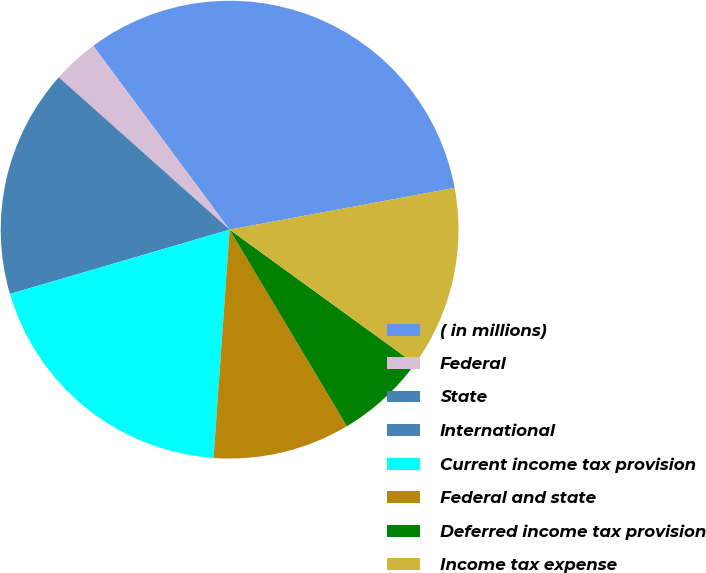Convert chart. <chart><loc_0><loc_0><loc_500><loc_500><pie_chart><fcel>( in millions)<fcel>Federal<fcel>State<fcel>International<fcel>Current income tax provision<fcel>Federal and state<fcel>Deferred income tax provision<fcel>Income tax expense<nl><fcel>32.24%<fcel>3.24%<fcel>0.01%<fcel>16.12%<fcel>19.35%<fcel>9.68%<fcel>6.46%<fcel>12.9%<nl></chart> 